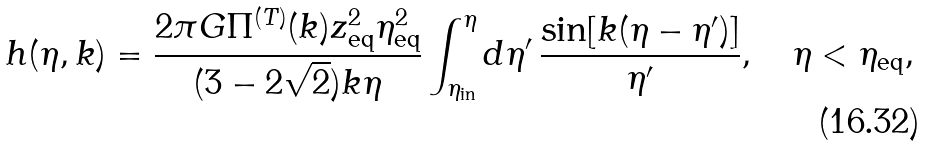<formula> <loc_0><loc_0><loc_500><loc_500>h ( \eta , k ) = \frac { 2 \pi G \Pi ^ { ( T ) } ( k ) z ^ { 2 } _ { \text {eq} } \eta ^ { 2 } _ { \text {eq} } } { ( 3 - 2 \sqrt { 2 } ) k \eta } \int ^ { \eta } _ { \eta _ { \text {in} } } d \eta ^ { \prime } \, \frac { \sin [ k ( \eta - \eta ^ { \prime } ) ] } { \eta ^ { \prime } } , \quad \eta < \eta _ { \text {eq} } ,</formula> 